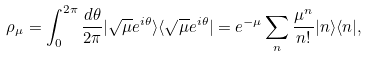<formula> <loc_0><loc_0><loc_500><loc_500>\rho _ { \mu } = \int _ { 0 } ^ { 2 \pi } \frac { d \theta } { 2 \pi } | \sqrt { \mu } e ^ { i \theta } \rangle \langle \sqrt { \mu } e ^ { i \theta } | = e ^ { - \mu } \sum _ { n } \frac { \mu ^ { n } } { n ! } | n \rangle \langle n | ,</formula> 